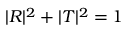Convert formula to latex. <formula><loc_0><loc_0><loc_500><loc_500>| R | ^ { 2 } + | T | ^ { 2 } = 1</formula> 